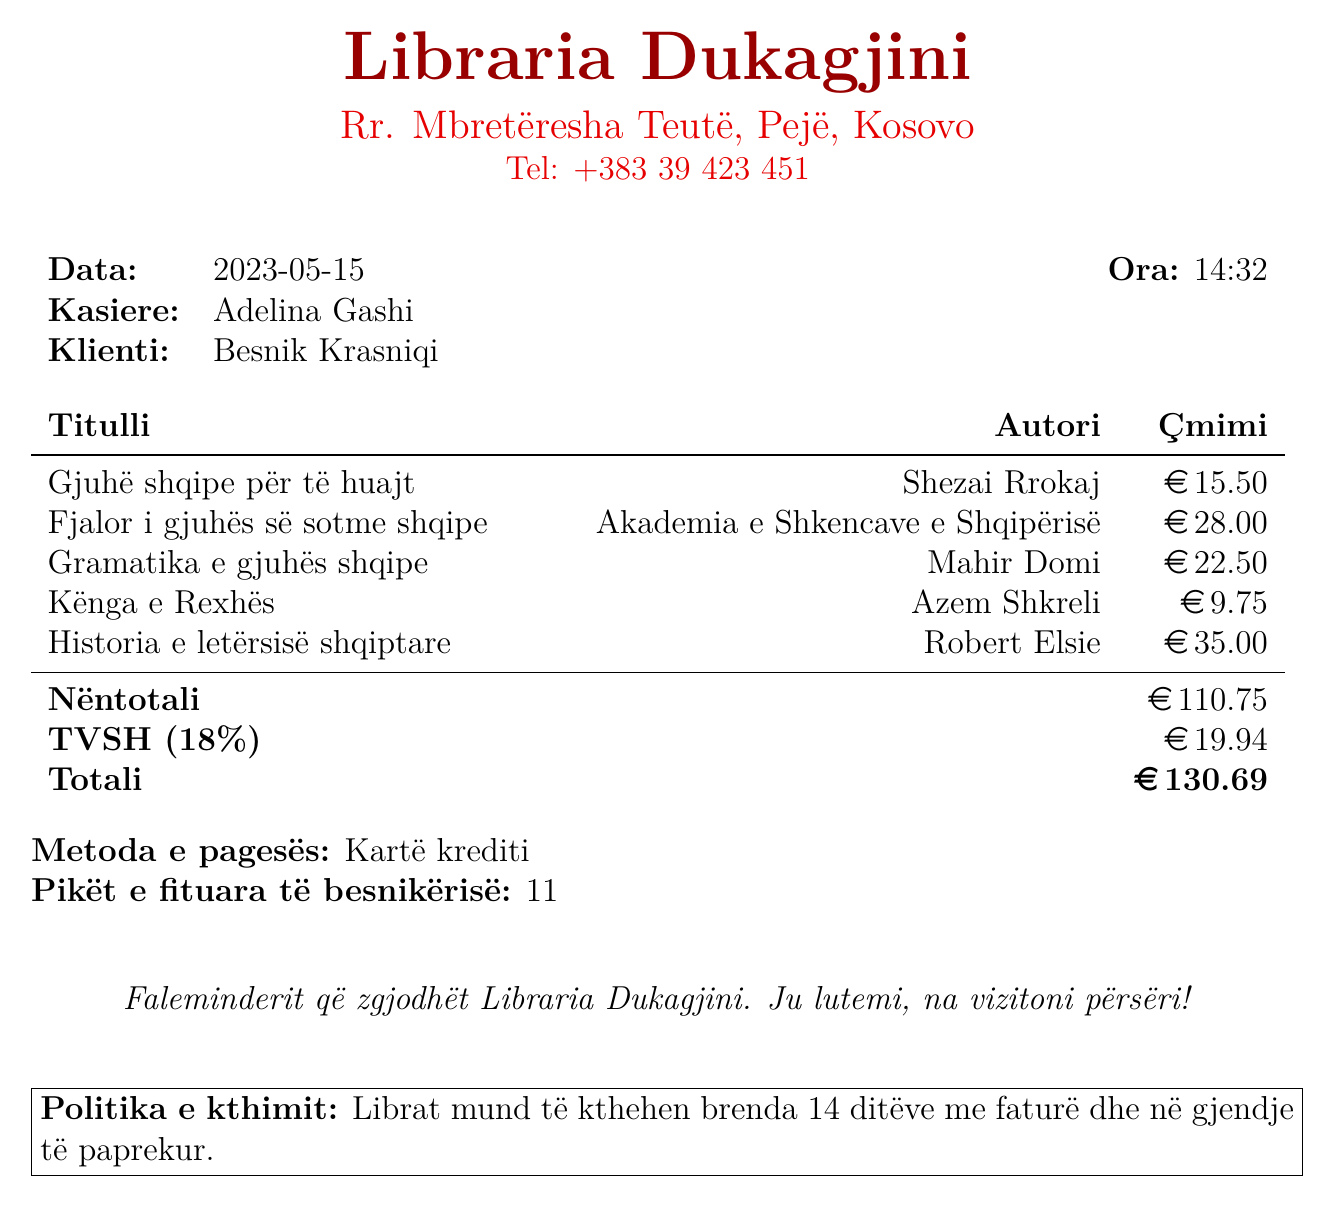What is the name of the bookstore? The name of the bookstore is stated at the top of the document.
Answer: Libraria Dukagjini What date was the purchase made? The date is clearly indicated on the receipt.
Answer: 2023-05-15 Who is the cashier for this transaction? The name of the cashier is mentioned in the receipt details.
Answer: Adelina Gashi What is the total price of all items purchased? The total price is given in the financial summary of the receipt.
Answer: 130.69 How many loyalty points were earned? The number of loyalty points is listed as a separate item at the bottom of the receipt.
Answer: 11 What is the return policy for the books? The return policy is detailed in the last section of the document.
Answer: Librat mund të kthehen brenda 14 ditëve me faturë dhe në gjendje të paprekur Which item has the highest price? The titles along with their prices allow us to identify the most expensive item.
Answer: Historia e letërsisë shqiptare How much was the tax amount on this purchase? The tax amount is provided explicitly in the financial breakdown of the receipt.
Answer: 19.94 What payment method was used for the purchase? The payment method is stated clearly in the payment section of the receipt.
Answer: Kartë krediti 